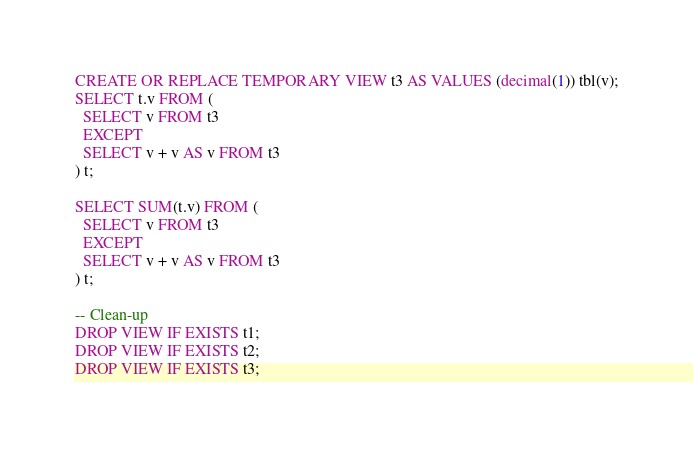Convert code to text. <code><loc_0><loc_0><loc_500><loc_500><_SQL_>CREATE OR REPLACE TEMPORARY VIEW t3 AS VALUES (decimal(1)) tbl(v);
SELECT t.v FROM (
  SELECT v FROM t3
  EXCEPT
  SELECT v + v AS v FROM t3
) t;

SELECT SUM(t.v) FROM (
  SELECT v FROM t3
  EXCEPT
  SELECT v + v AS v FROM t3
) t;

-- Clean-up
DROP VIEW IF EXISTS t1;
DROP VIEW IF EXISTS t2;
DROP VIEW IF EXISTS t3;
</code> 